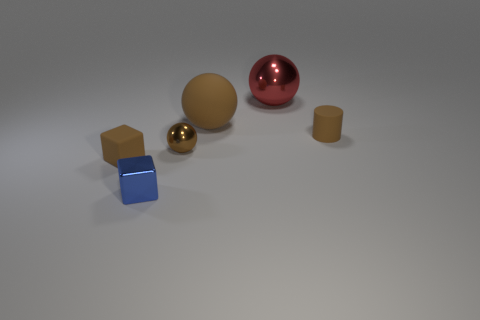What shape is the metal thing that is behind the tiny brown matte object that is on the right side of the tiny block that is in front of the matte block?
Offer a terse response. Sphere. The thing that is behind the brown rubber cylinder and in front of the red shiny sphere is made of what material?
Give a very brief answer. Rubber. There is a small brown thing that is behind the brown sphere in front of the matte cylinder; what is its shape?
Provide a succinct answer. Cylinder. Is there anything else that is the same color as the matte cylinder?
Keep it short and to the point. Yes. There is a red object; is it the same size as the brown shiny thing on the left side of the tiny cylinder?
Your answer should be compact. No. What number of small things are either rubber blocks or matte cylinders?
Ensure brevity in your answer.  2. Is the number of small matte things greater than the number of tiny blue balls?
Provide a succinct answer. Yes. There is a metal ball behind the metal ball that is in front of the large metal object; how many metal spheres are to the left of it?
Offer a very short reply. 1. The small blue metallic thing has what shape?
Ensure brevity in your answer.  Cube. What number of other things are made of the same material as the cylinder?
Make the answer very short. 2. 